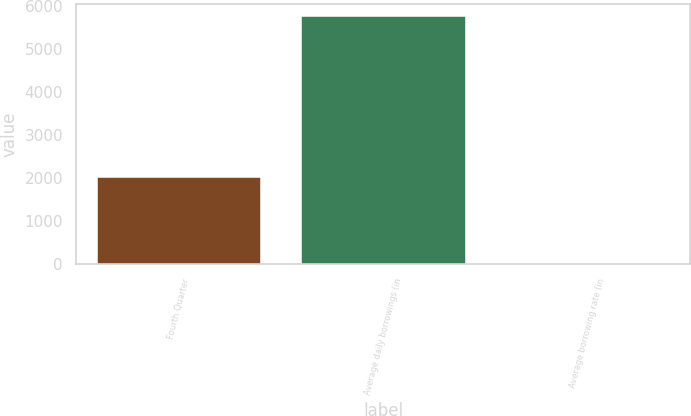<chart> <loc_0><loc_0><loc_500><loc_500><bar_chart><fcel>Fourth Quarter<fcel>Average daily borrowings (in<fcel>Average borrowing rate (in<nl><fcel>2015<fcel>5756<fcel>6.8<nl></chart> 